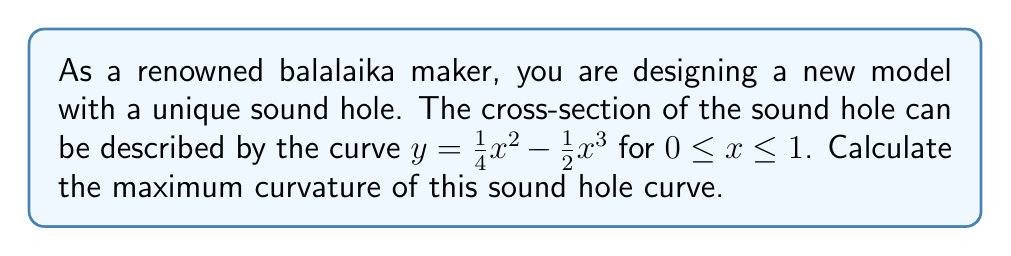Solve this math problem. To find the maximum curvature of the sound hole curve, we'll follow these steps:

1) The curvature formula for a function $y(x)$ is given by:

   $$\kappa = \frac{|y''|}{(1 + (y')^2)^{3/2}}$$

2) First, let's find $y'$ and $y''$:
   
   $y' = \frac{1}{2}x - \frac{3}{2}x^2$
   $y'' = \frac{1}{2} - 3x$

3) Now, we substitute these into the curvature formula:

   $$\kappa = \frac{|\frac{1}{2} - 3x|}{(1 + (\frac{1}{2}x - \frac{3}{2}x^2)^2)^{3/2}}$$

4) To find the maximum curvature, we need to find where $\frac{d\kappa}{dx} = 0$. However, this leads to a complex equation. Instead, we can observe that the numerator will be maximum when $x = \frac{1}{6}$ (making the absolute value term maximum).

5) Let's evaluate the curvature at $x = 0$, $x = \frac{1}{6}$, and $x = 1$:

   At $x = 0$: $\kappa = \frac{1}{2}$
   
   At $x = \frac{1}{6}$: $\kappa \approx 0.5204$
   
   At $x = 1$: $\kappa \approx 0.4811$

6) The maximum curvature occurs at $x = \frac{1}{6}$, with a value of approximately 0.5204.
Answer: $\kappa_{max} \approx 0.5204$ at $x = \frac{1}{6}$ 